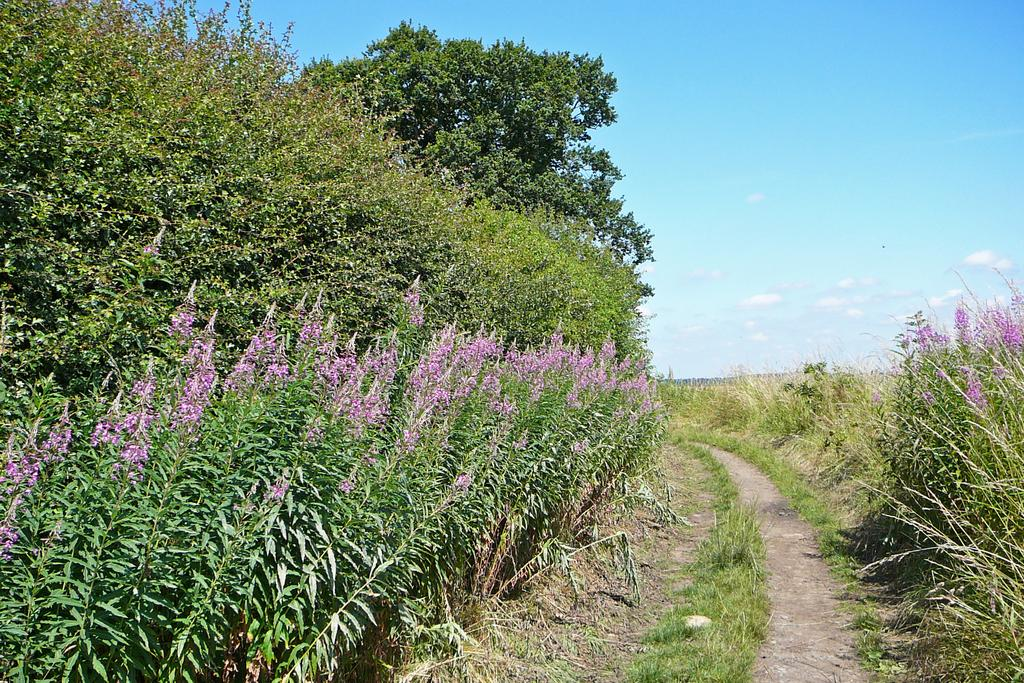What type of plants can be seen in the image? There are small plants with violet color flowers in the image. What is visible in the background of the image? There are many trees behind the plants. What is the ground made of in the image? There is grass on the ground in the image. Is there any path or walkway visible in the image? Yes, there is a path in the image. What type of toothbrush is being used to draw on the trees in the image? There is no toothbrush or drawing activity present in the image. What type of wilderness or remote area is depicted in the image? The image does not depict a wilderness or remote area; it features plants, trees, grass, and a path. 